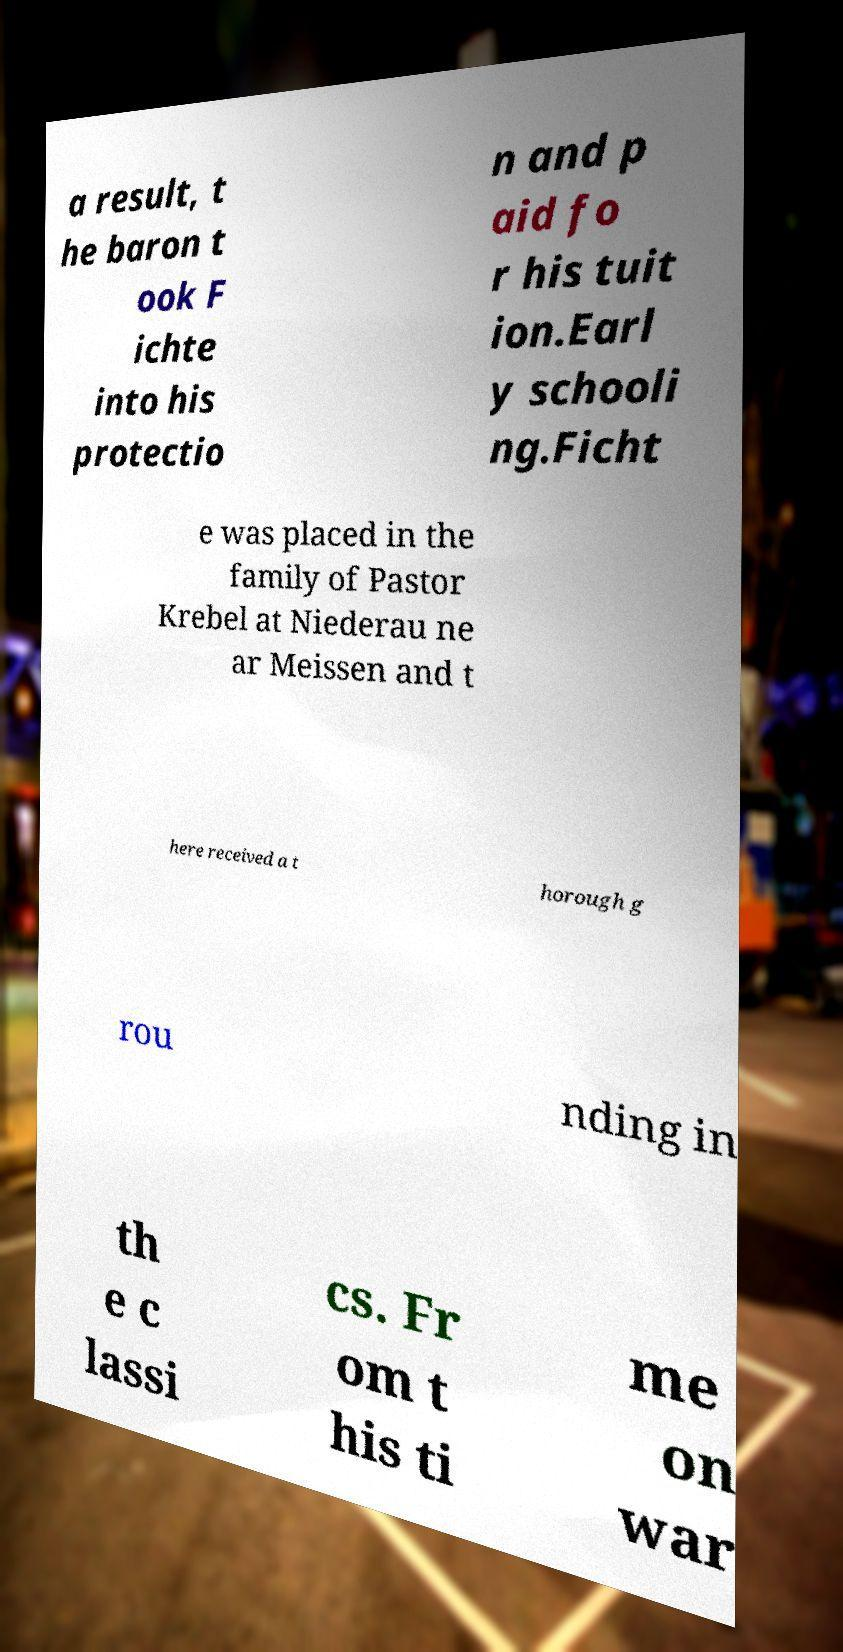There's text embedded in this image that I need extracted. Can you transcribe it verbatim? a result, t he baron t ook F ichte into his protectio n and p aid fo r his tuit ion.Earl y schooli ng.Ficht e was placed in the family of Pastor Krebel at Niederau ne ar Meissen and t here received a t horough g rou nding in th e c lassi cs. Fr om t his ti me on war 